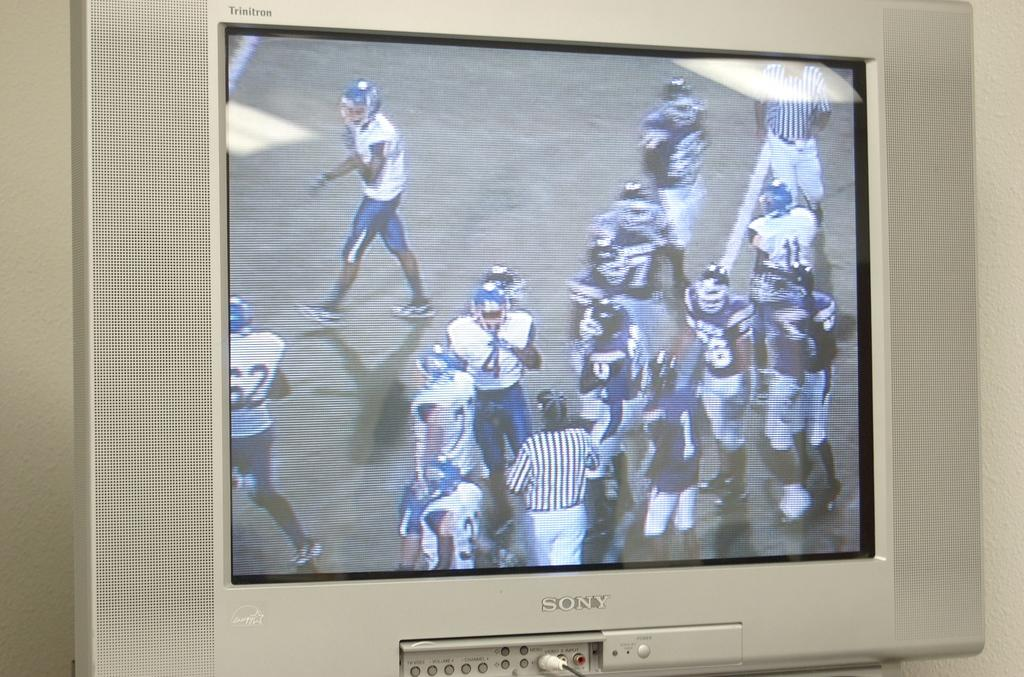<image>
Create a compact narrative representing the image presented. Silver sony television with video input and menu buttons. 